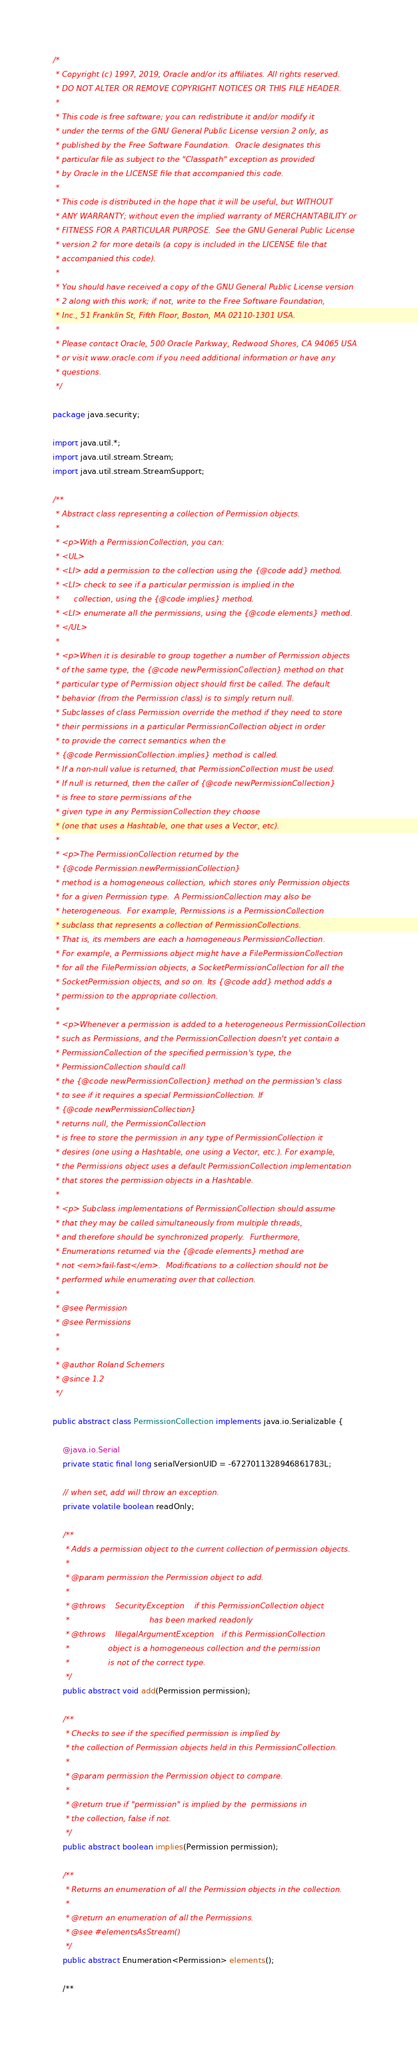Convert code to text. <code><loc_0><loc_0><loc_500><loc_500><_Java_>/*
 * Copyright (c) 1997, 2019, Oracle and/or its affiliates. All rights reserved.
 * DO NOT ALTER OR REMOVE COPYRIGHT NOTICES OR THIS FILE HEADER.
 *
 * This code is free software; you can redistribute it and/or modify it
 * under the terms of the GNU General Public License version 2 only, as
 * published by the Free Software Foundation.  Oracle designates this
 * particular file as subject to the "Classpath" exception as provided
 * by Oracle in the LICENSE file that accompanied this code.
 *
 * This code is distributed in the hope that it will be useful, but WITHOUT
 * ANY WARRANTY; without even the implied warranty of MERCHANTABILITY or
 * FITNESS FOR A PARTICULAR PURPOSE.  See the GNU General Public License
 * version 2 for more details (a copy is included in the LICENSE file that
 * accompanied this code).
 *
 * You should have received a copy of the GNU General Public License version
 * 2 along with this work; if not, write to the Free Software Foundation,
 * Inc., 51 Franklin St, Fifth Floor, Boston, MA 02110-1301 USA.
 *
 * Please contact Oracle, 500 Oracle Parkway, Redwood Shores, CA 94065 USA
 * or visit www.oracle.com if you need additional information or have any
 * questions.
 */

package java.security;

import java.util.*;
import java.util.stream.Stream;
import java.util.stream.StreamSupport;

/**
 * Abstract class representing a collection of Permission objects.
 *
 * <p>With a PermissionCollection, you can:
 * <UL>
 * <LI> add a permission to the collection using the {@code add} method.
 * <LI> check to see if a particular permission is implied in the
 *      collection, using the {@code implies} method.
 * <LI> enumerate all the permissions, using the {@code elements} method.
 * </UL>
 *
 * <p>When it is desirable to group together a number of Permission objects
 * of the same type, the {@code newPermissionCollection} method on that
 * particular type of Permission object should first be called. The default
 * behavior (from the Permission class) is to simply return null.
 * Subclasses of class Permission override the method if they need to store
 * their permissions in a particular PermissionCollection object in order
 * to provide the correct semantics when the
 * {@code PermissionCollection.implies} method is called.
 * If a non-null value is returned, that PermissionCollection must be used.
 * If null is returned, then the caller of {@code newPermissionCollection}
 * is free to store permissions of the
 * given type in any PermissionCollection they choose
 * (one that uses a Hashtable, one that uses a Vector, etc).
 *
 * <p>The PermissionCollection returned by the
 * {@code Permission.newPermissionCollection}
 * method is a homogeneous collection, which stores only Permission objects
 * for a given Permission type.  A PermissionCollection may also be
 * heterogeneous.  For example, Permissions is a PermissionCollection
 * subclass that represents a collection of PermissionCollections.
 * That is, its members are each a homogeneous PermissionCollection.
 * For example, a Permissions object might have a FilePermissionCollection
 * for all the FilePermission objects, a SocketPermissionCollection for all the
 * SocketPermission objects, and so on. Its {@code add} method adds a
 * permission to the appropriate collection.
 *
 * <p>Whenever a permission is added to a heterogeneous PermissionCollection
 * such as Permissions, and the PermissionCollection doesn't yet contain a
 * PermissionCollection of the specified permission's type, the
 * PermissionCollection should call
 * the {@code newPermissionCollection} method on the permission's class
 * to see if it requires a special PermissionCollection. If
 * {@code newPermissionCollection}
 * returns null, the PermissionCollection
 * is free to store the permission in any type of PermissionCollection it
 * desires (one using a Hashtable, one using a Vector, etc.). For example,
 * the Permissions object uses a default PermissionCollection implementation
 * that stores the permission objects in a Hashtable.
 *
 * <p> Subclass implementations of PermissionCollection should assume
 * that they may be called simultaneously from multiple threads,
 * and therefore should be synchronized properly.  Furthermore,
 * Enumerations returned via the {@code elements} method are
 * not <em>fail-fast</em>.  Modifications to a collection should not be
 * performed while enumerating over that collection.
 *
 * @see Permission
 * @see Permissions
 *
 *
 * @author Roland Schemers
 * @since 1.2
 */

public abstract class PermissionCollection implements java.io.Serializable {

    @java.io.Serial
    private static final long serialVersionUID = -6727011328946861783L;

    // when set, add will throw an exception.
    private volatile boolean readOnly;

    /**
     * Adds a permission object to the current collection of permission objects.
     *
     * @param permission the Permission object to add.
     *
     * @throws    SecurityException    if this PermissionCollection object
     *                                 has been marked readonly
     * @throws    IllegalArgumentException   if this PermissionCollection
     *                object is a homogeneous collection and the permission
     *                is not of the correct type.
     */
    public abstract void add(Permission permission);

    /**
     * Checks to see if the specified permission is implied by
     * the collection of Permission objects held in this PermissionCollection.
     *
     * @param permission the Permission object to compare.
     *
     * @return true if "permission" is implied by the  permissions in
     * the collection, false if not.
     */
    public abstract boolean implies(Permission permission);

    /**
     * Returns an enumeration of all the Permission objects in the collection.
     *
     * @return an enumeration of all the Permissions.
     * @see #elementsAsStream()
     */
    public abstract Enumeration<Permission> elements();

    /**</code> 